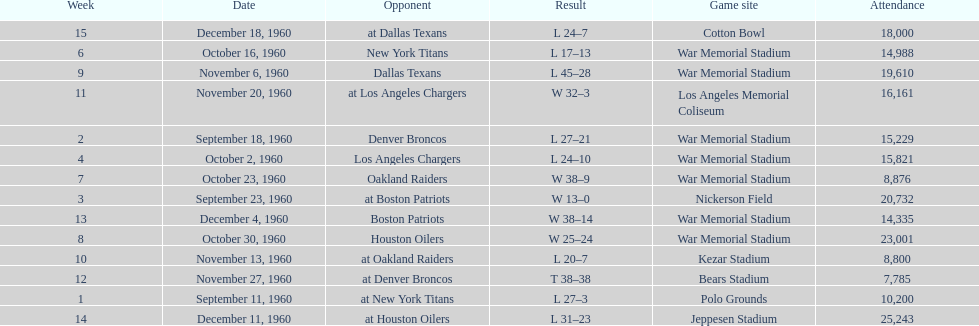Who was the only opponent they played which resulted in a tie game? Denver Broncos. 